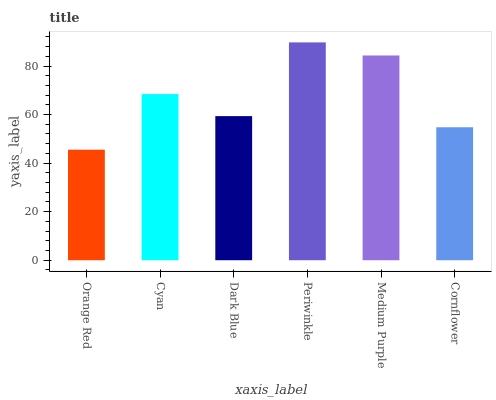Is Orange Red the minimum?
Answer yes or no. Yes. Is Periwinkle the maximum?
Answer yes or no. Yes. Is Cyan the minimum?
Answer yes or no. No. Is Cyan the maximum?
Answer yes or no. No. Is Cyan greater than Orange Red?
Answer yes or no. Yes. Is Orange Red less than Cyan?
Answer yes or no. Yes. Is Orange Red greater than Cyan?
Answer yes or no. No. Is Cyan less than Orange Red?
Answer yes or no. No. Is Cyan the high median?
Answer yes or no. Yes. Is Dark Blue the low median?
Answer yes or no. Yes. Is Orange Red the high median?
Answer yes or no. No. Is Cyan the low median?
Answer yes or no. No. 